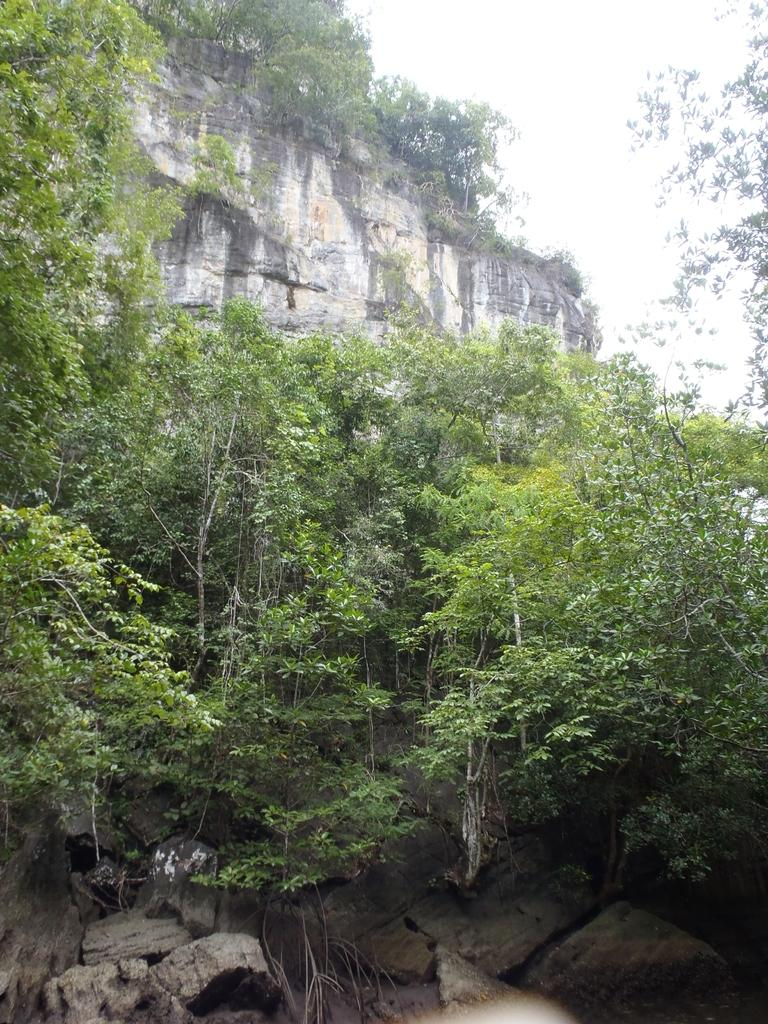What type of natural formation can be seen in the image? There are mountains in the image. What is located in the center of the image? There are many trees in the center of the image. What part of the sky is visible in the image? The sky is visible in the top right of the image. What type of ground surface is present at the bottom of the image? There are stones at the bottom of the image. What type of rhythm can be heard coming from the mountains in the image? There is no sound or rhythm present in the image; it is a still image of mountains, trees, sky, and stones. 